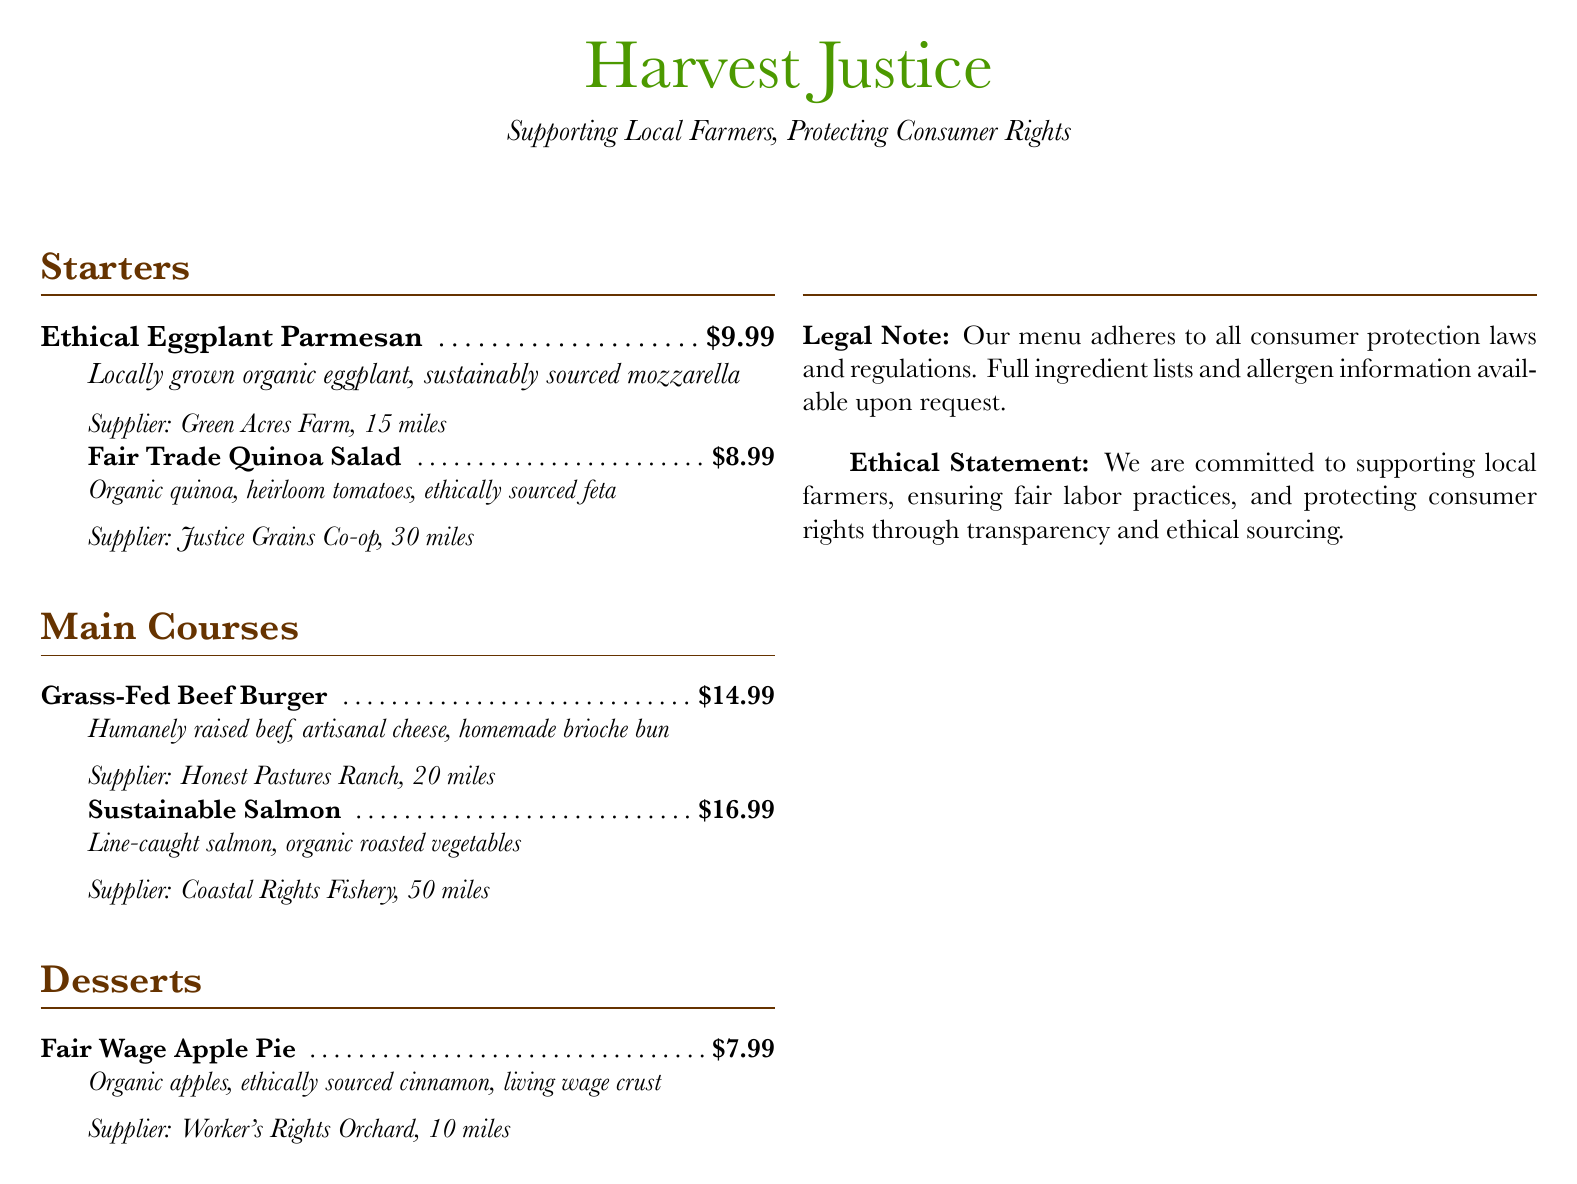What is the name of the restaurant? The name of the restaurant is featured prominently at the top of the menu.
Answer: Harvest Justice What ingredient in the Grass-Fed Beef Burger is sourced from local farms? The menu specifies that the beef is humanely raised, indicating local sourcing.
Answer: Beef How much does the Fair Wage Apple Pie cost? The price for the Fair Wage Apple Pie is clearly listed next to the menu item.
Answer: $7.99 How far is Green Acres Farm from the restaurant? The distance to the supplier is provided in the menu item description.
Answer: 15 miles What type of fish is used in the Sustainable Salmon dish? The dish description mentions the specific type of fish used.
Answer: Salmon What is the ethical sourcing commitment mentioned in the menu? The ethical statement highlights the restaurant's dedication to transparency and labor practices.
Answer: Transparency and ethical sourcing Who supplies the Fair Trade Quinoa Salad? The supplier for the salad is clearly indicated in the menu.
Answer: Justice Grains Co-op How many miles away is Coastal Rights Fishery? The distance for this specific supplier is stated in the menu.
Answer: 50 miles Which dish features ethically sourced cinnamon? The dessert description includes the specific ingredient that is ethically sourced.
Answer: Fair Wage Apple Pie 